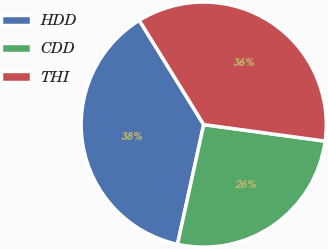Convert chart to OTSL. <chart><loc_0><loc_0><loc_500><loc_500><pie_chart><fcel>HDD<fcel>CDD<fcel>THI<nl><fcel>37.76%<fcel>26.28%<fcel>35.97%<nl></chart> 